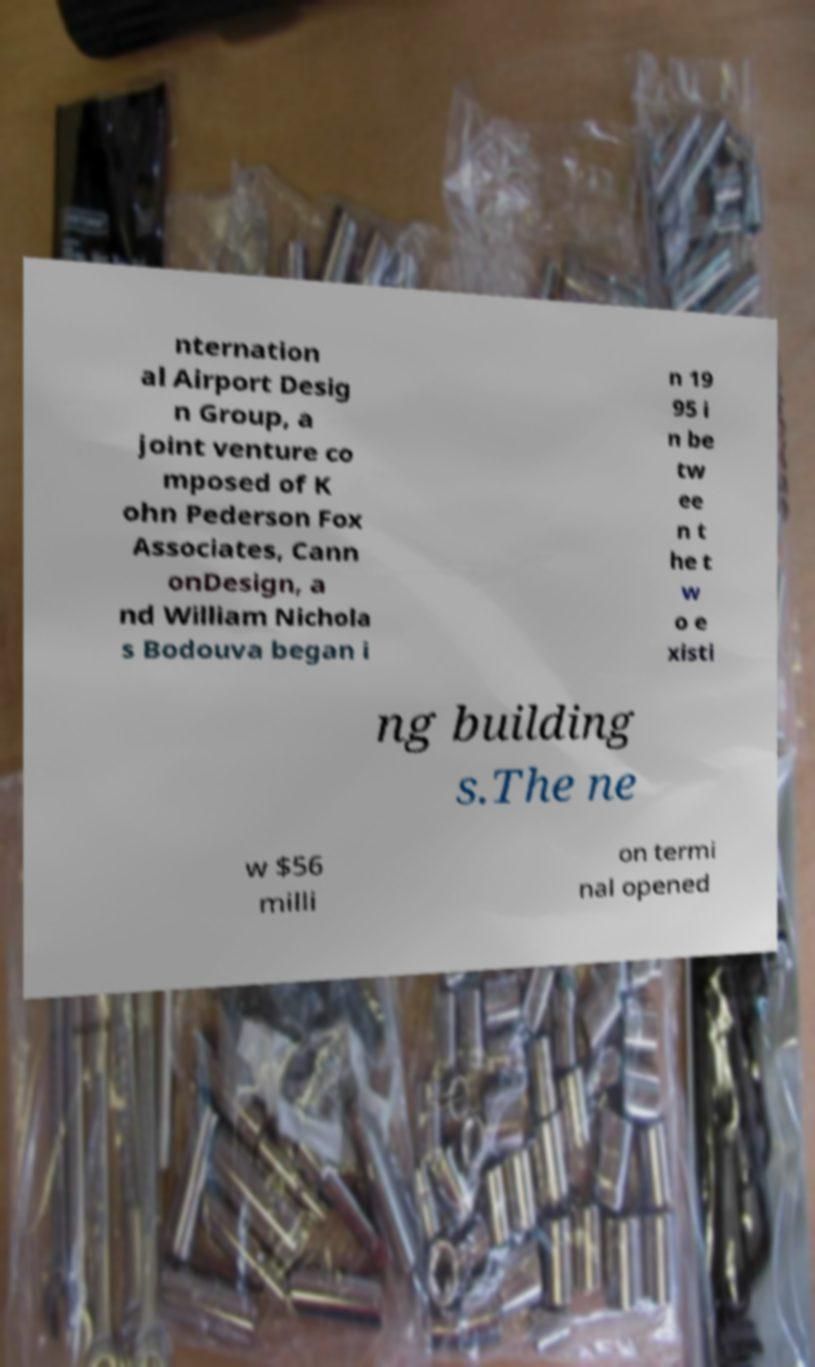Could you assist in decoding the text presented in this image and type it out clearly? nternation al Airport Desig n Group, a joint venture co mposed of K ohn Pederson Fox Associates, Cann onDesign, a nd William Nichola s Bodouva began i n 19 95 i n be tw ee n t he t w o e xisti ng building s.The ne w $56 milli on termi nal opened 